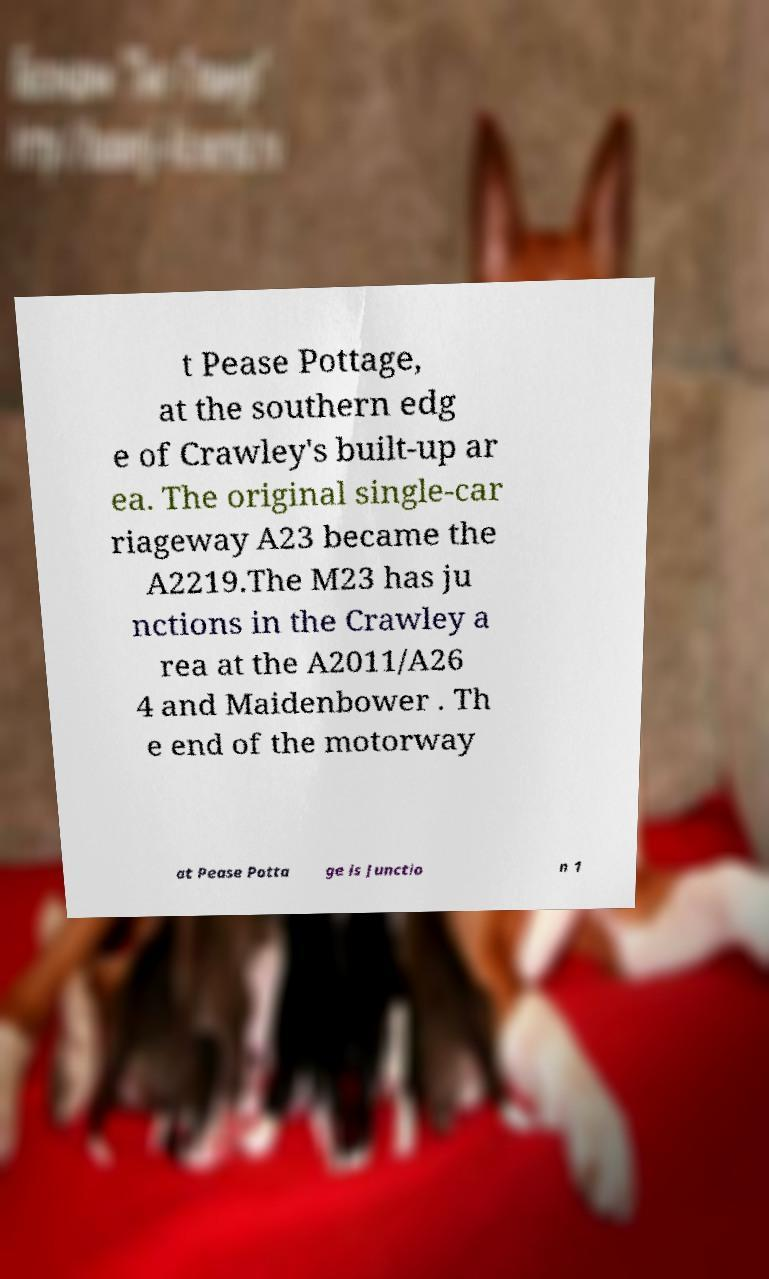Please read and relay the text visible in this image. What does it say? t Pease Pottage, at the southern edg e of Crawley's built-up ar ea. The original single-car riageway A23 became the A2219.The M23 has ju nctions in the Crawley a rea at the A2011/A26 4 and Maidenbower . Th e end of the motorway at Pease Potta ge is Junctio n 1 